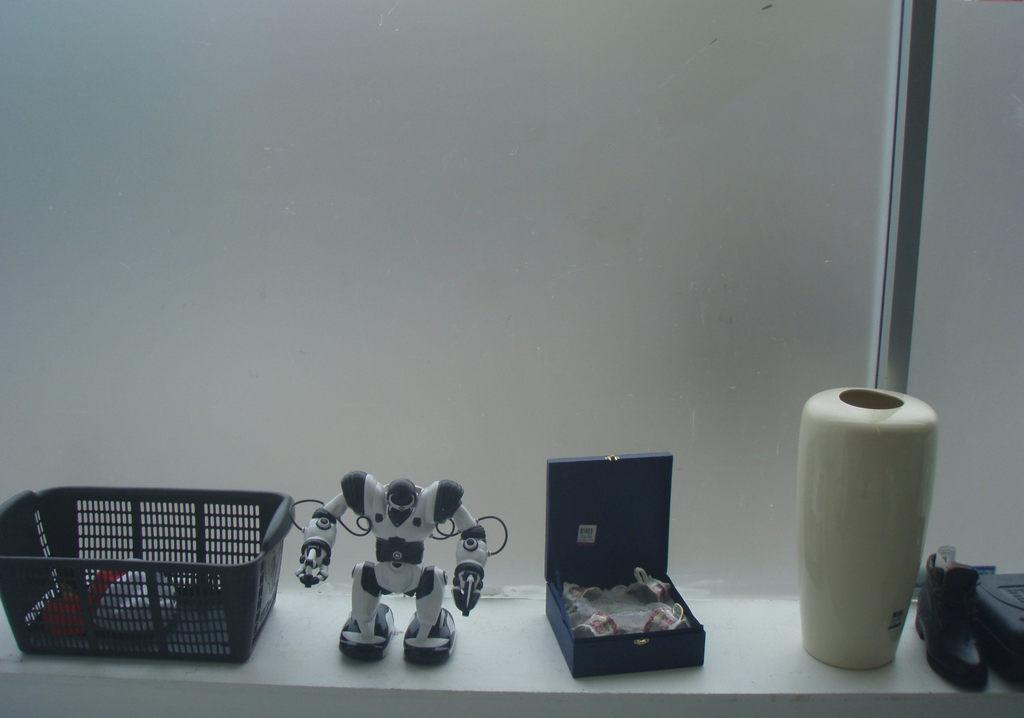Please provide a concise description of this image. In this picture we can see a basket, robot toy, base, shoe on a platform. 